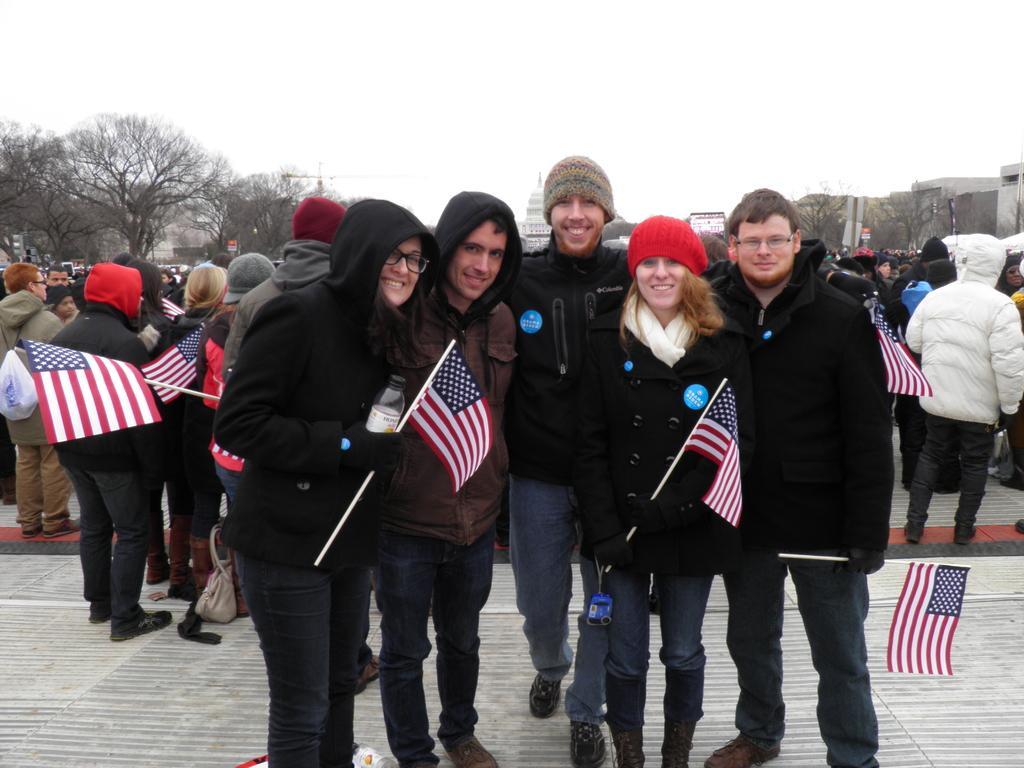Describe this image in one or two sentences. In the image there are few people standing and holding the flags in their hands. There are caps on their heads. And there is a person holding the bottle in the hand. In the background there are trees and also there are few buildings. At the top of the image there is a sky. 